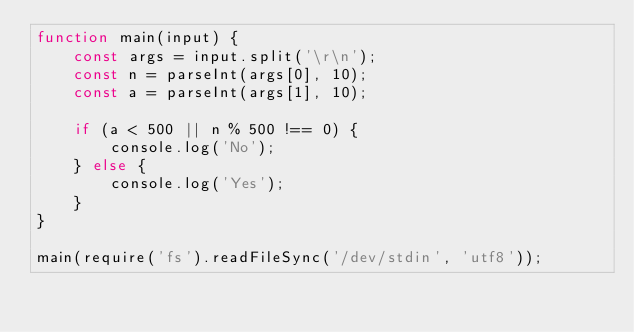<code> <loc_0><loc_0><loc_500><loc_500><_JavaScript_>function main(input) {
    const args = input.split('\r\n');
    const n = parseInt(args[0], 10);
    const a = parseInt(args[1], 10);

    if (a < 500 || n % 500 !== 0) {
        console.log('No');
    } else {
        console.log('Yes');
    }
}

main(require('fs').readFileSync('/dev/stdin', 'utf8'));</code> 